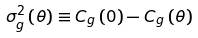Convert formula to latex. <formula><loc_0><loc_0><loc_500><loc_500>\sigma _ { g } ^ { 2 } \left ( \theta \right ) \equiv C _ { g } \left ( 0 \right ) - C _ { g } \left ( \theta \right )</formula> 